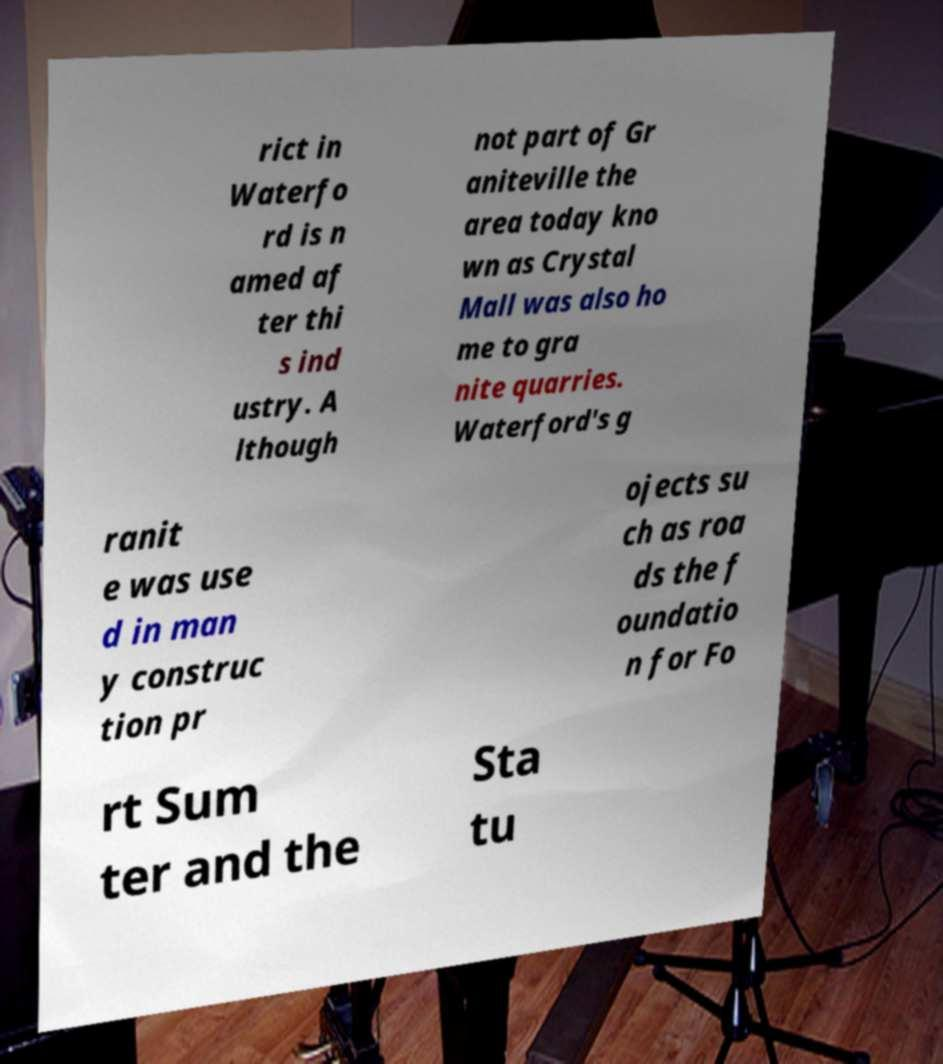Please read and relay the text visible in this image. What does it say? rict in Waterfo rd is n amed af ter thi s ind ustry. A lthough not part of Gr aniteville the area today kno wn as Crystal Mall was also ho me to gra nite quarries. Waterford's g ranit e was use d in man y construc tion pr ojects su ch as roa ds the f oundatio n for Fo rt Sum ter and the Sta tu 